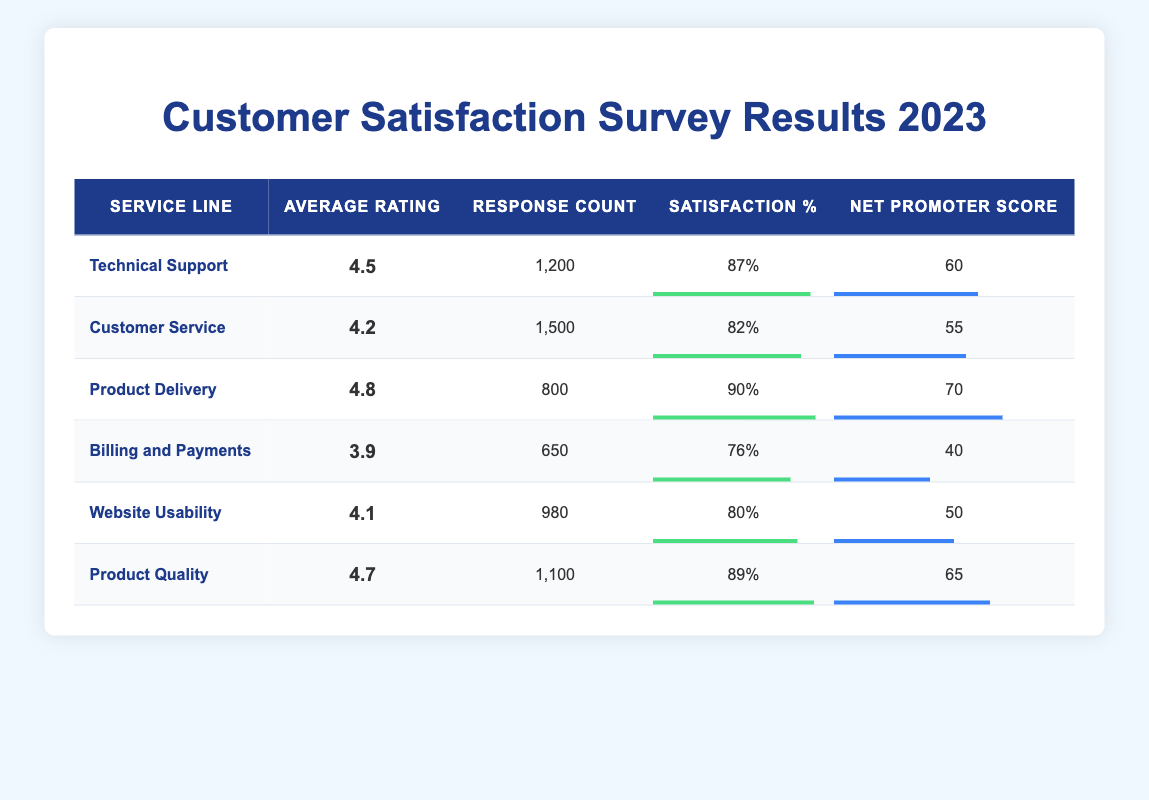What is the average rating for the Technical Support service line? The table states that the average rating for Technical Support is explicitly listed as 4.5.
Answer: 4.5 Which service line has the highest satisfaction percentage? By comparing satisfaction percentages from all service lines, Product Delivery has the highest satisfaction percentage at 90%.
Answer: Product Delivery How many total responses were collected across all service lines? The total can be calculated by summing the response counts: 1200 + 1500 + 800 + 650 + 980 + 1100 = 5230.
Answer: 5230 Is the average rating for Customer Service greater than 4.0? The average rating is directly listed in the table as 4.2, which is indeed greater than 4.0.
Answer: Yes What is the difference in Net Promoter Score between Product Delivery and Billing and Payments? The Net Promoter Score for Product Delivery is 70, and for Billing and Payments, it's 40. The difference is calculated by subtracting: 70 - 40 = 30.
Answer: 30 What is the average Net Promoter Score for all service lines? To find the average NPS, sum the scores (60 + 55 + 70 + 40 + 50 + 65 = 340) and divide by the number of service lines (6): 340 / 6 ≈ 56.67.
Answer: Approximately 56.67 Are there more responses for Product Quality than for Website Usability? Product Quality has 1100 responses while Website Usability has 980. Since 1100 is greater than 980, the answer is affirmative.
Answer: Yes Which service line has the lowest average rating, and what is that rating? By examining the average ratings, Billing and Payments has the lowest average rating listed as 3.9.
Answer: Billing and Payments, 3.9 Are all service lines' satisfaction percentages 80% or higher? Checking the satisfaction percentages reveals that Billing and Payments has a satisfaction percentage of 76%, which is below 80%. Hence, not all service lines meet the criterion.
Answer: No 